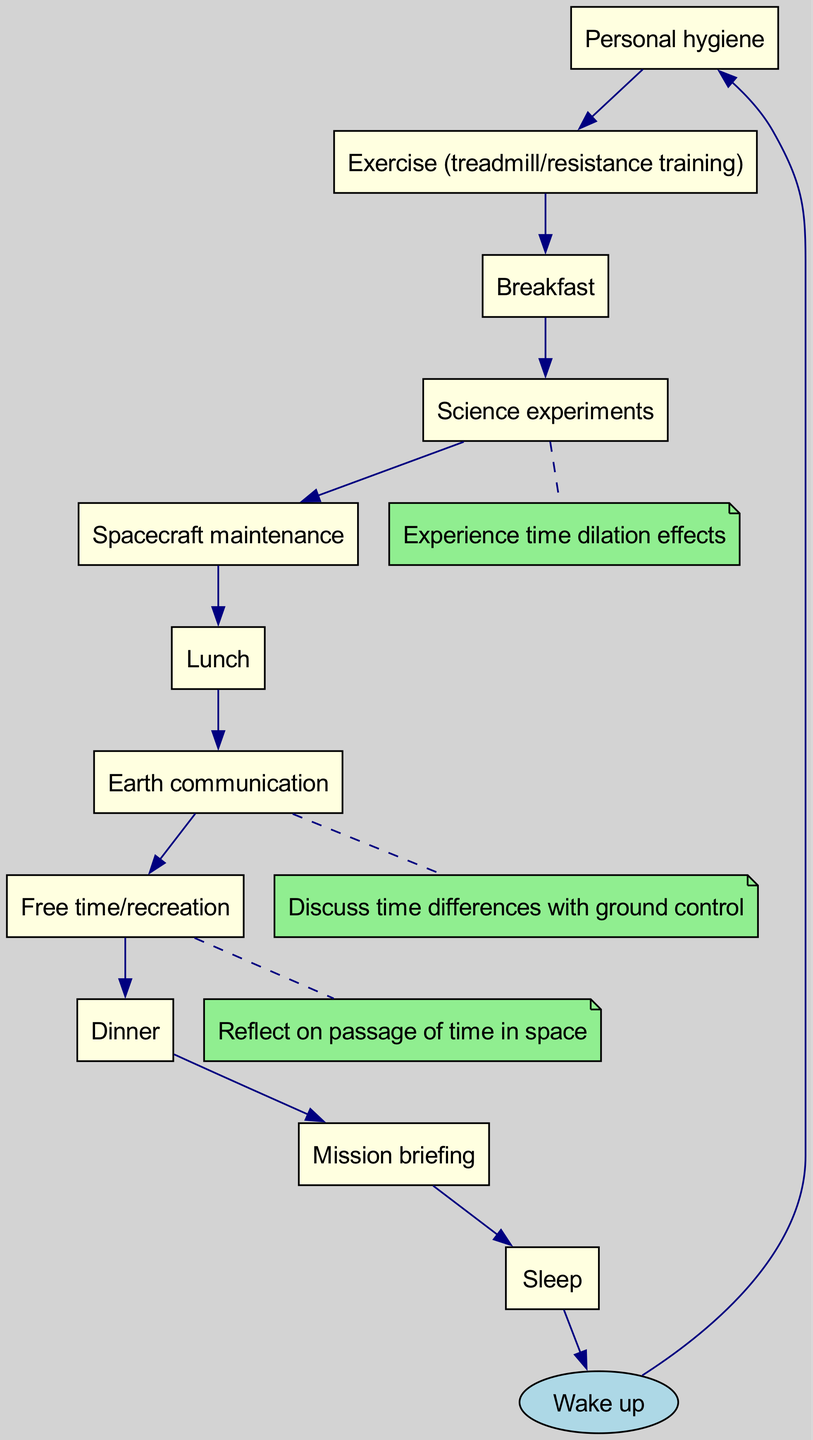What is the first activity after "Wake up"? The diagram shows that the first activity after "Wake up" is "Personal hygiene." The flowchart explicitly connects "Wake up" to "Personal hygiene" as the next node.
Answer: Personal hygiene How many nodes are there in the diagram? The diagram lists a total of 11 nodes, including the start node "Wake up." Each node represents a different activity in the daily routine of an astronaut.
Answer: 11 What is the last activity before going to sleep? According to the flowchart, the last activity before "Sleep" is "Mission briefing." The arrow connects "Mission briefing" directly to "Sleep" as the final node.
Answer: Mission briefing Which activity experiences time dilation effects? The diagram states that "Science experiments" is the activity that experiences time dilation effects, as indicated by the associated note connected to this node.
Answer: Science experiments What activity follows "Earth communication"? The diagram indicates that "Free time/recreation" follows "Earth communication." There is a directed arrow showing this flow between the two activities.
Answer: Free time/recreation How many edges are there in total? Counting the edges shown in the diagram, there are 11 edges connecting the various activities that outline the daily routine. This includes the connections between all the nodes.
Answer: 11 In which activity is time reflection discussed? The diagram mentions "Free time/recreation" as the activity where reflecting on the passage of time in space occurs, supported by the note attached to this node.
Answer: Free time/recreation What is the activity immediately before lunch? The flowchart specifies that the activity immediately preceding "Lunch" is "Spacecraft maintenance." This is shown by the directed connection leading to the lunch node.
Answer: Spacecraft maintenance Which activity directly connects to "Exercise (treadmill/resistance training)"? The diagram shows that "Breakfast" directly connects to "Exercise (treadmill/resistance training)," indicating that "Breakfast" follows the exercise activity.
Answer: Breakfast 